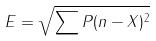<formula> <loc_0><loc_0><loc_500><loc_500>E = \sqrt { \sum P ( n - X ) ^ { 2 } }</formula> 